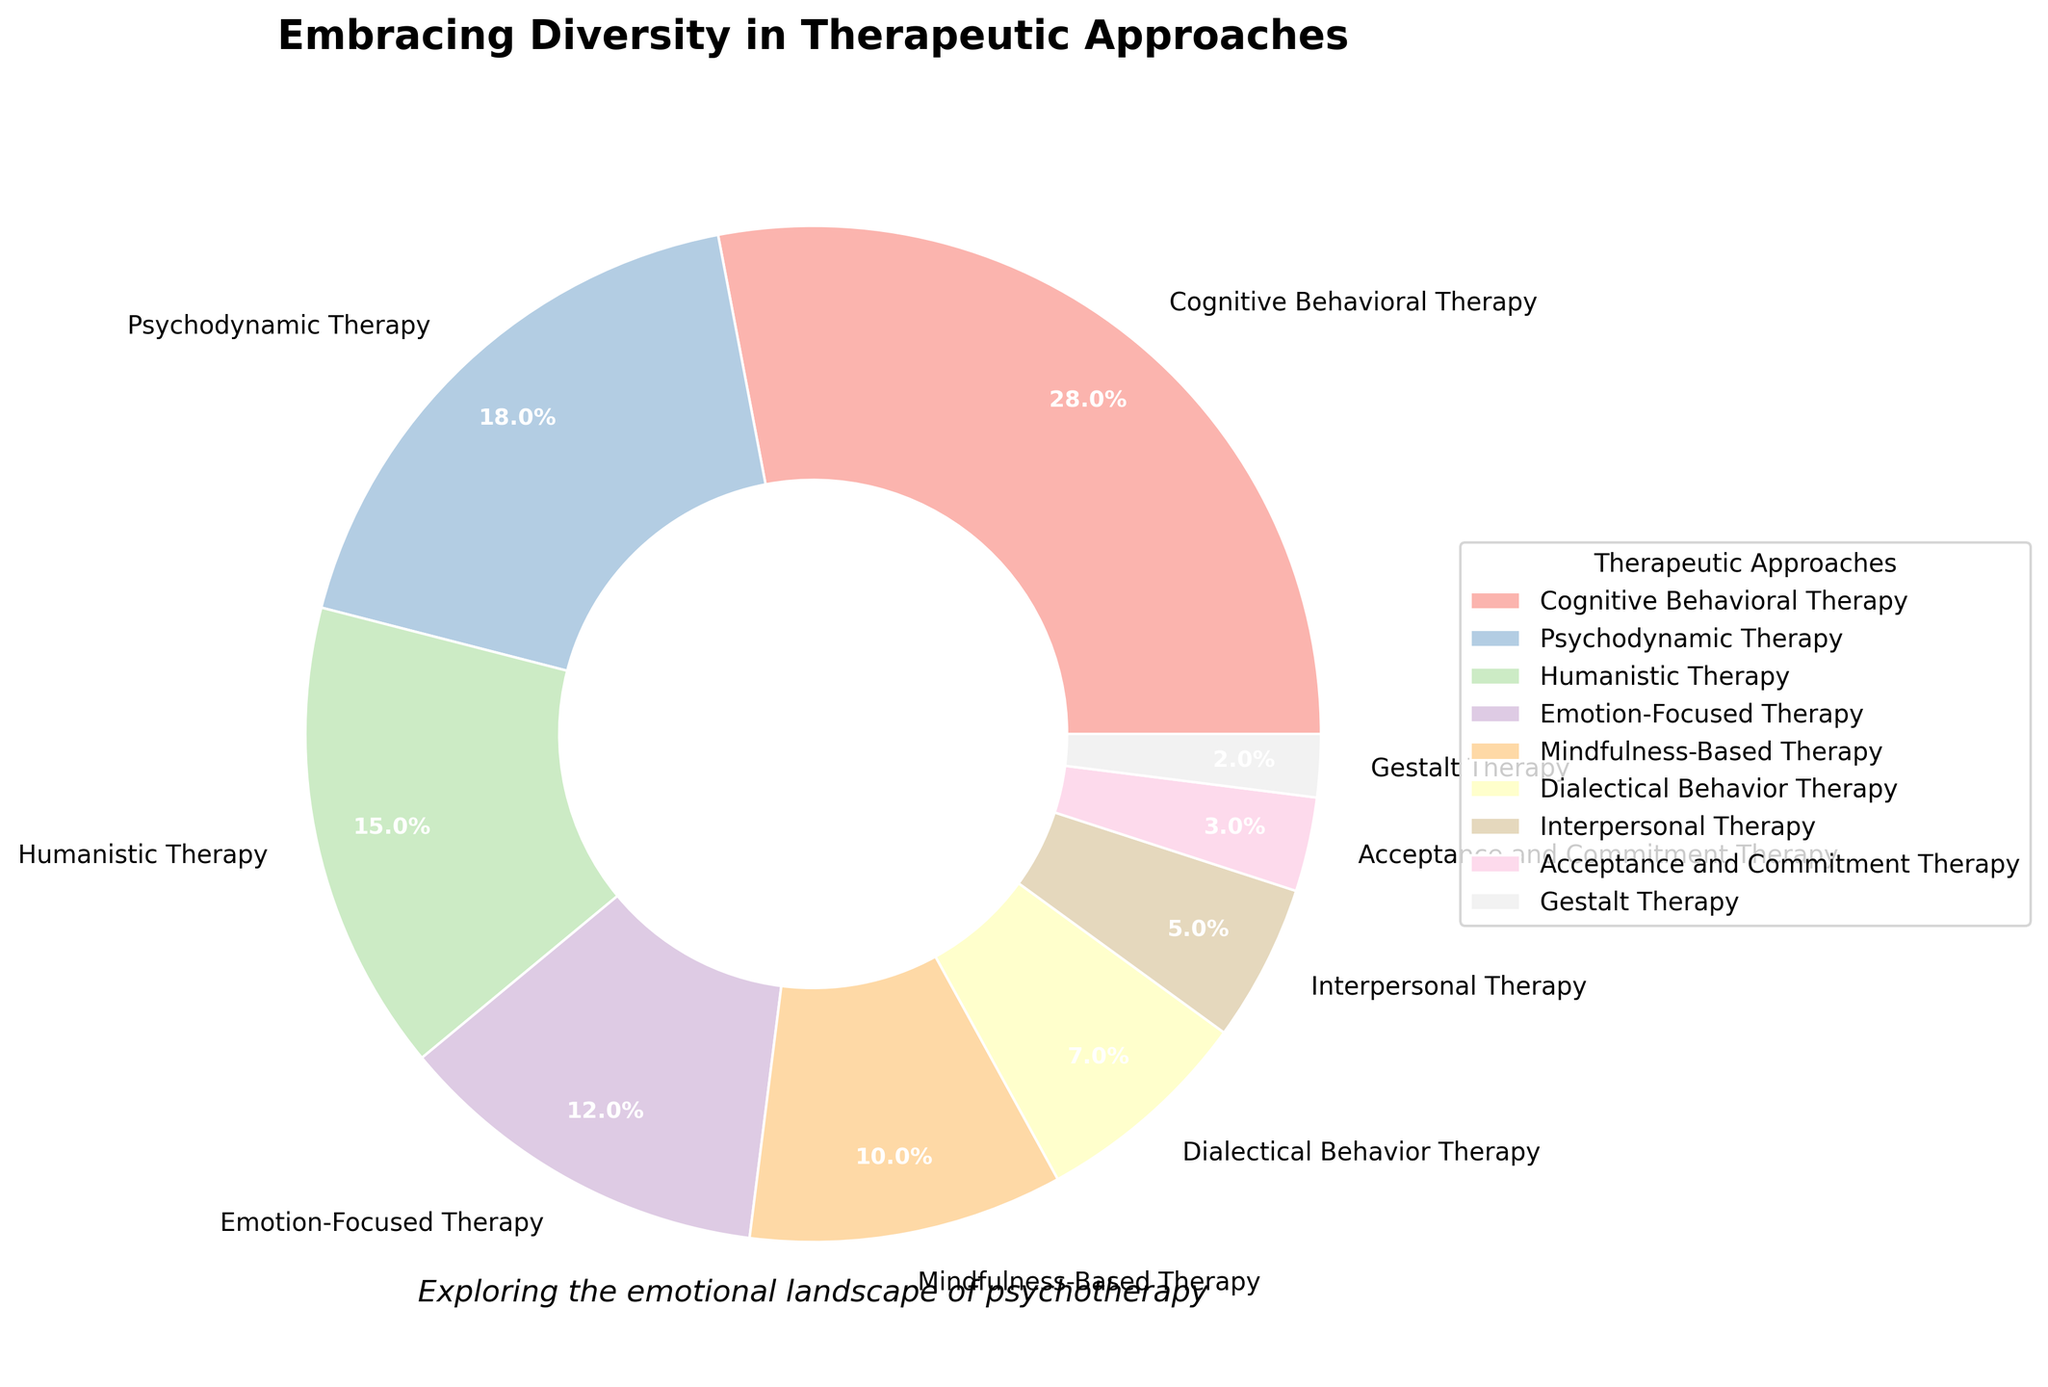Which therapeutic approach has the highest percentage? To find the therapeutic approach with the highest percentage, look for the largest wedge in the pie chart and refer to its label. The largest wedge represents Cognitive Behavioral Therapy.
Answer: Cognitive Behavioral Therapy What is the combined percentage for Humanistic Therapy and Mindfulness-Based Therapy? Add the percentages of Humanistic Therapy (15%) and Mindfulness-Based Therapy (10%) by locating their wedges and summing up the values.
Answer: 25% Which approach has a larger percentage, Emotion-Focused Therapy or Interpersonal Therapy? Compare the wedges of Emotion-Focused Therapy (12%) and Interpersonal Therapy (5%). Emotion-Focused Therapy has a larger wedge.
Answer: Emotion-Focused Therapy What are the two least preferred therapeutic approaches? Identify the two smallest wedges in the pie chart, which are Gestalt Therapy (2%) and Acceptance and Commitment Therapy (3%).
Answer: Gestalt Therapy, Acceptance and Commitment Therapy What is the total percentage of the top three most preferred therapeutic approaches? Add the percentages of the top three approaches: Cognitive Behavioral Therapy (28%), Psychodynamic Therapy (18%), and Humanistic Therapy (15%). Sum = 28% + 18% + 15% = 61%.
Answer: 61% Is the percentage of Dialectical Behavior Therapy greater than or equal to the percentage of Interpersonal Therapy and Gestalt Therapy combined? Compare Dialectical Behavior Therapy (7%) to the combined values of Interpersonal Therapy (5%) and Gestalt Therapy (2%). The combined value is 7%, which equals the percentage of Dialectical Behavior Therapy.
Answer: Yes Which therapeutic approach has a light pink color in the pie chart? Identify the wedge with the light pink color by observing the chart visually and checking its label. The light pink wedge corresponds to Humanistic Therapy.
Answer: Humanistic Therapy 